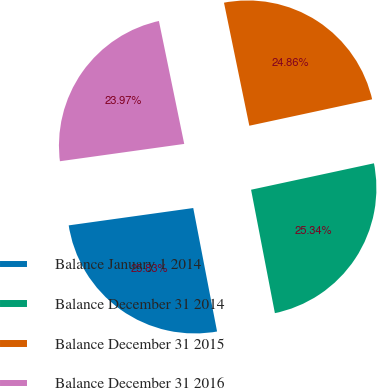Convert chart. <chart><loc_0><loc_0><loc_500><loc_500><pie_chart><fcel>Balance January 1 2014<fcel>Balance December 31 2014<fcel>Balance December 31 2015<fcel>Balance December 31 2016<nl><fcel>25.83%<fcel>25.34%<fcel>24.86%<fcel>23.97%<nl></chart> 